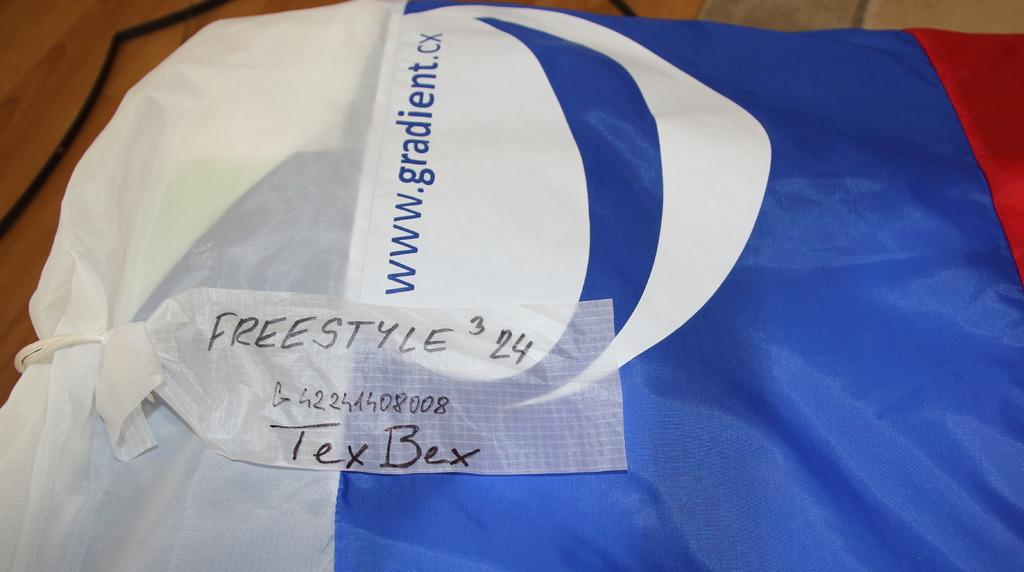What is present on the costume in the image? The costume has a label on it. Where is the costume located in the image? The costume is placed on a table. What type of guitar is being played by the person wearing the costume in the image? There is no person wearing the costume or playing a guitar in the image. How many cushions are placed on the table next to the costume in the image? There is no mention of cushions in the image; only the costume and its label are present. 